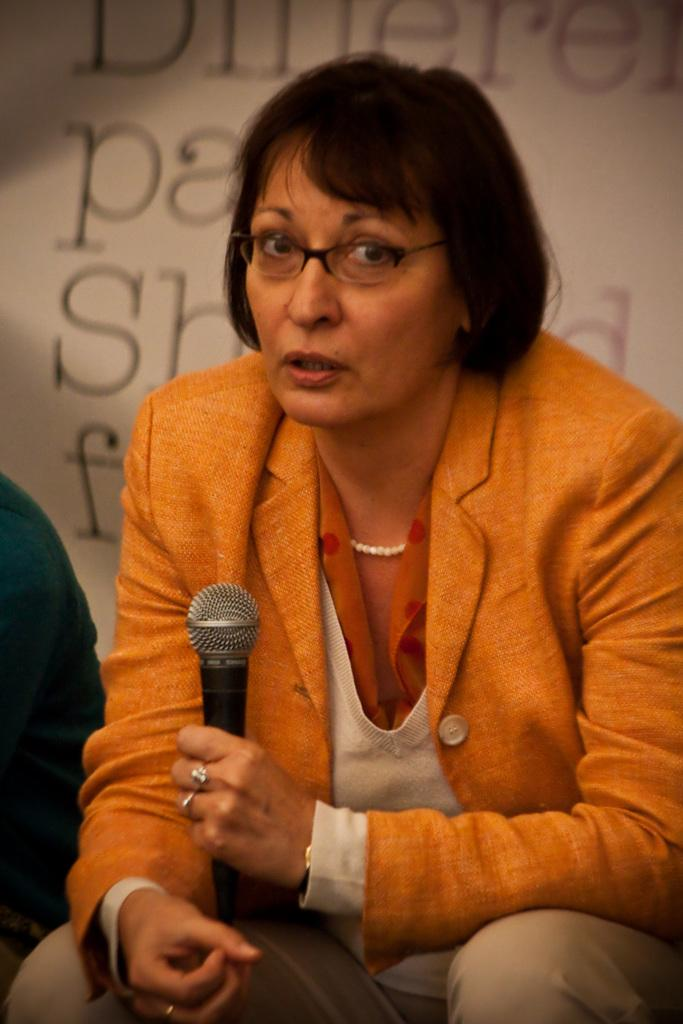What is the main subject of the image? The main subject of the image is a woman. What is the woman doing in the image? The woman is sitting in the image. What object is the woman holding? The woman is holding a mic in the image. Can you describe anything visible on the backside of the image? There is text visible on the backside of the image. What type of shame can be seen on the woman's face in the image? There is no indication of shame on the woman's face in the image. Can you tell me how many boats are present in the harbor in the image? There is no harbor or boats present in the image. What season is depicted in the image? The provided facts do not indicate any specific season in the image. 